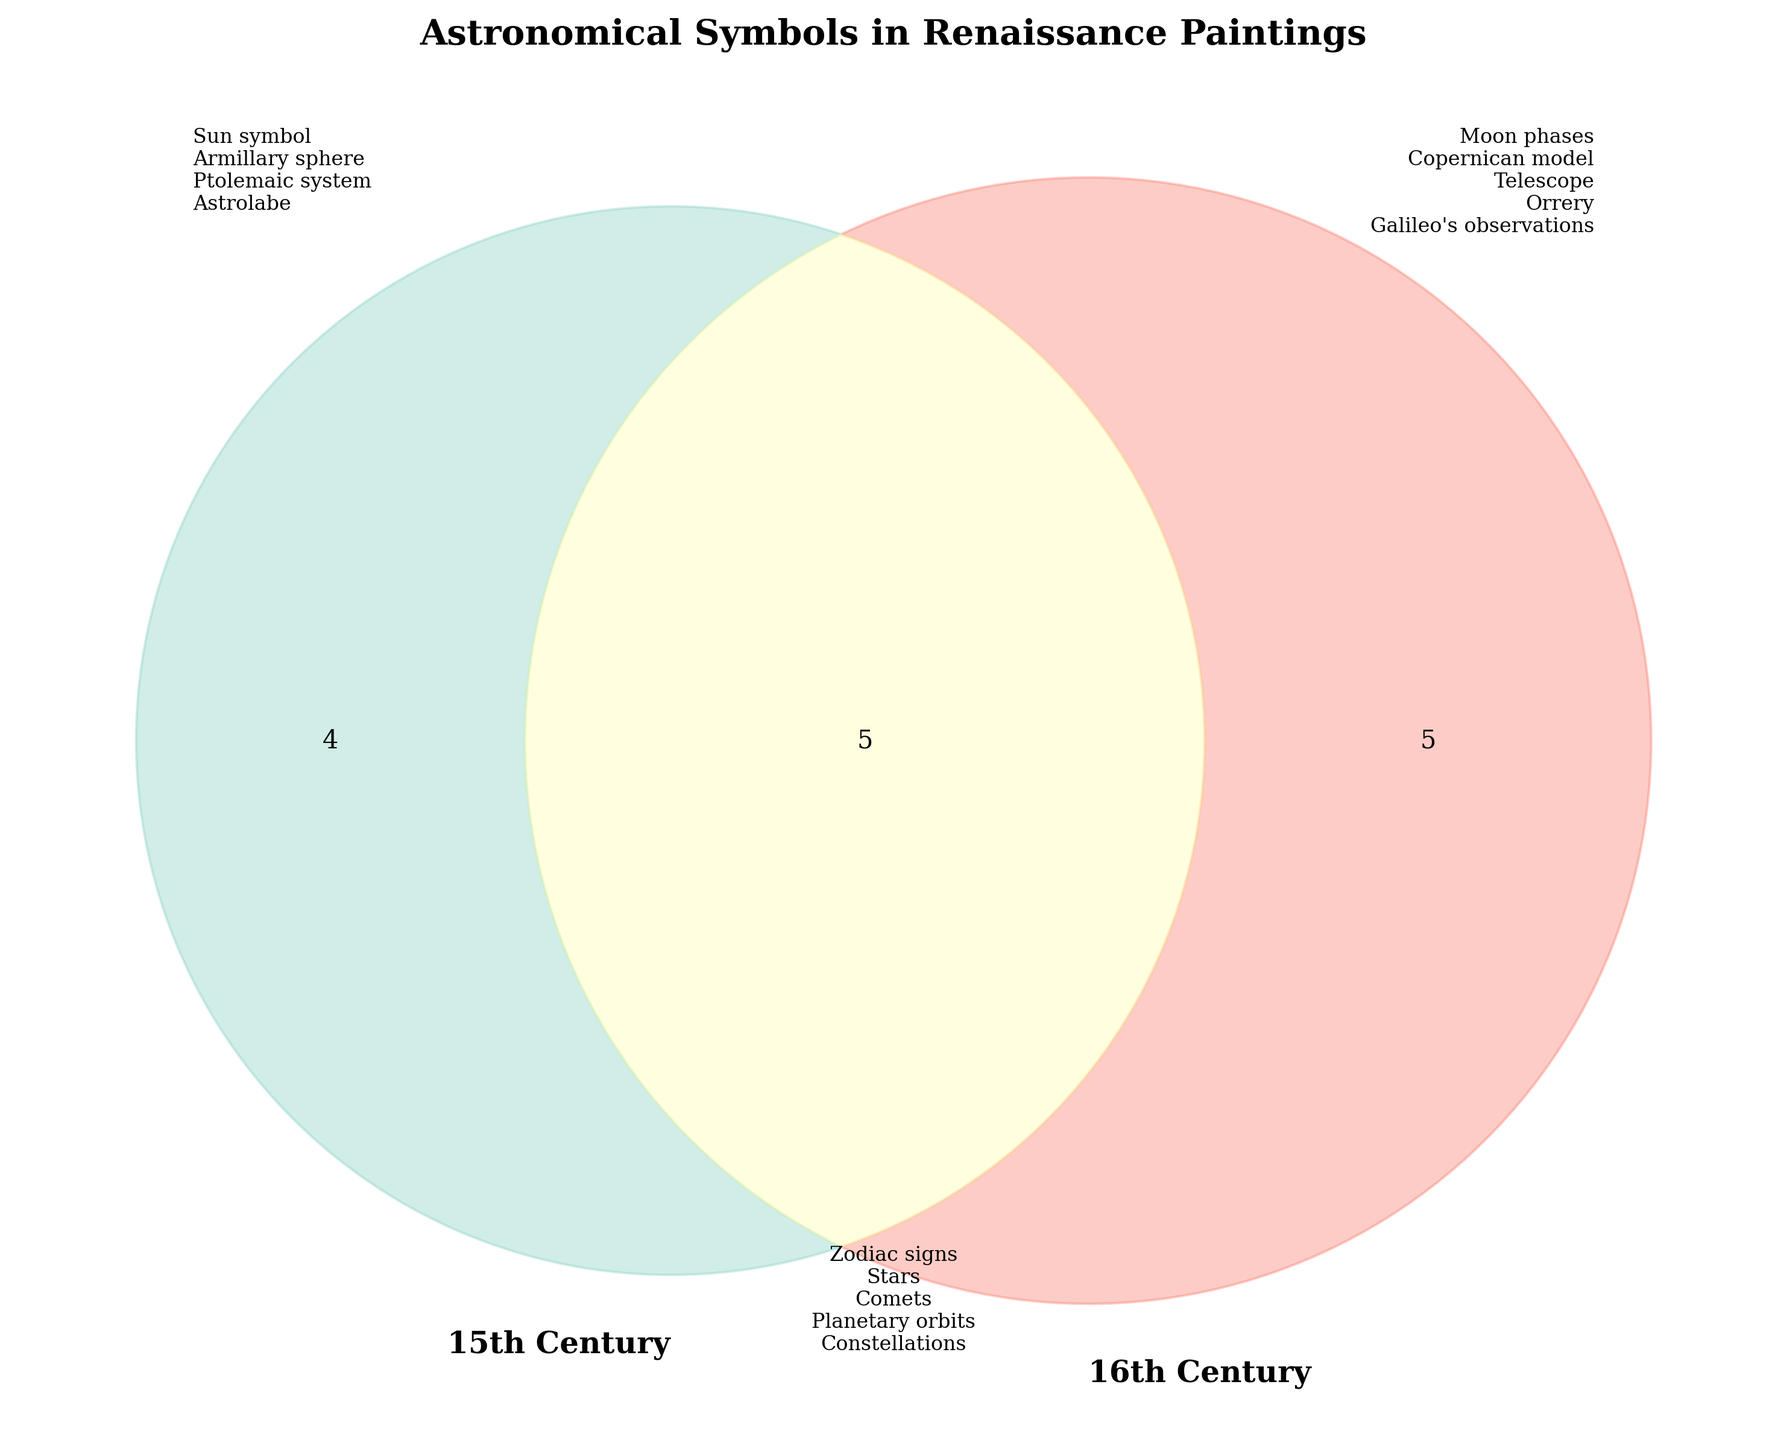What is the title of the figure? The title of the figure is located at the top of the diagram. It reads "Astronomical Symbols in Renaissance Paintings".
Answer: Astronomical Symbols in Renaissance Paintings What astronomical symbol is exclusively found in 15th-century paintings and not in 16th-century paintings? By looking at the left circle of the Venn diagram, which represents the 15th century, we see "Sun symbol", "Armillary sphere", "Ptolemaic system", and "Astrolabe". The first symbol listed is the "Sun symbol".
Answer: Sun symbol Which symbol is shared between both centuries? The common area in the middle of the Venn diagram, which represents symbols found in both centuries, contains "Zodiac signs", "Stars", "Comets", "Planetary orbits", and "Constellations".
Answer: Zodiac signs, Stars, Comets, Planetary orbits, Constellations What symbols are exclusive to the 16th century? The right circle of the Venn diagram, representing the 16th century, has "Moon phases", "Copernican model", "Telescope", "Orrery", and "Galileo's observations".
Answer: Moon phases, Copernican model, Telescope, Orrery, Galileo's observations How many astronomical symbols are shared between the 15th and 16th centuries? The number of symbols in the overlap region, representing both centuries, includes "Zodiac signs", "Stars", "Comets", "Planetary orbits", and "Constellations". Counting them gives 5 symbols.
Answer: 5 Which century features the Telescope as an astronomical symbol? By noting the symbol placement in the Venn diagram, we see "Telescope" is listed exclusively in the right circle meaning it was featured in 16th-century paintings.
Answer: 16th century How many unique astronomical symbols are there in total? Counting the unique symbols in each section of the Venn diagram: 4 symbols in 15th-century exclusive, 5 in 16th-century exclusive, and 5 in both. Total unique symbols = 4 + 5 + 5 = 14.
Answer: 14 What unique symbol appears exclusively in the 15th century but not in both centuries? The symbols exclusive to the 15th century and not in the overlap region are "Sun symbol", "Armillary sphere", "Ptolemaic system", and "Astrolabe".
Answer: Sun symbol, Armillary sphere, Ptolemaic system, Astrolabe 